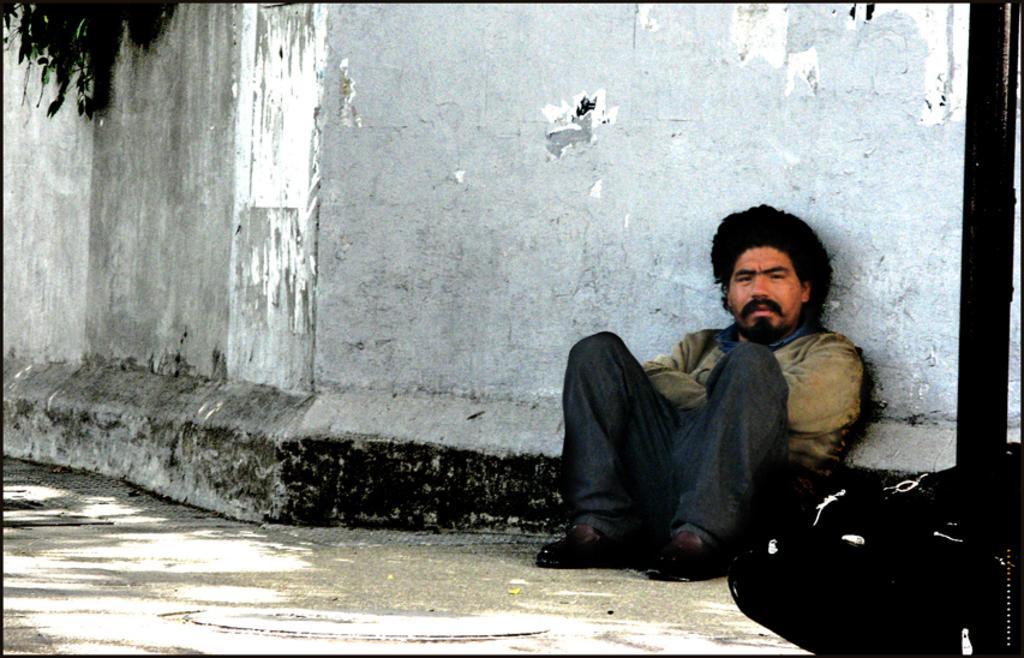Please provide a concise description of this image. In this picture I can see there is a man sitting on the walk way and there is a black color object on to right side and there is a wall in the backdrop and there is a plant in the backdrop. 